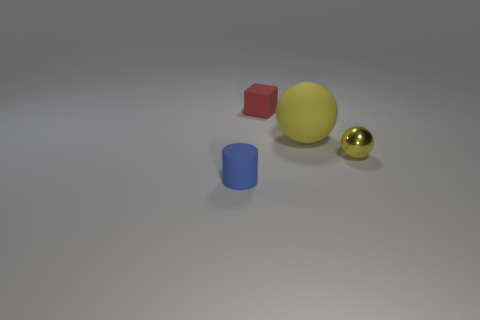Add 4 big matte cubes. How many objects exist? 8 Subtract all cubes. How many objects are left? 3 Add 2 small cyan metal cubes. How many small cyan metal cubes exist? 2 Subtract 0 purple cubes. How many objects are left? 4 Subtract all tiny brown rubber cylinders. Subtract all tiny blue things. How many objects are left? 3 Add 3 tiny blue rubber cylinders. How many tiny blue rubber cylinders are left? 4 